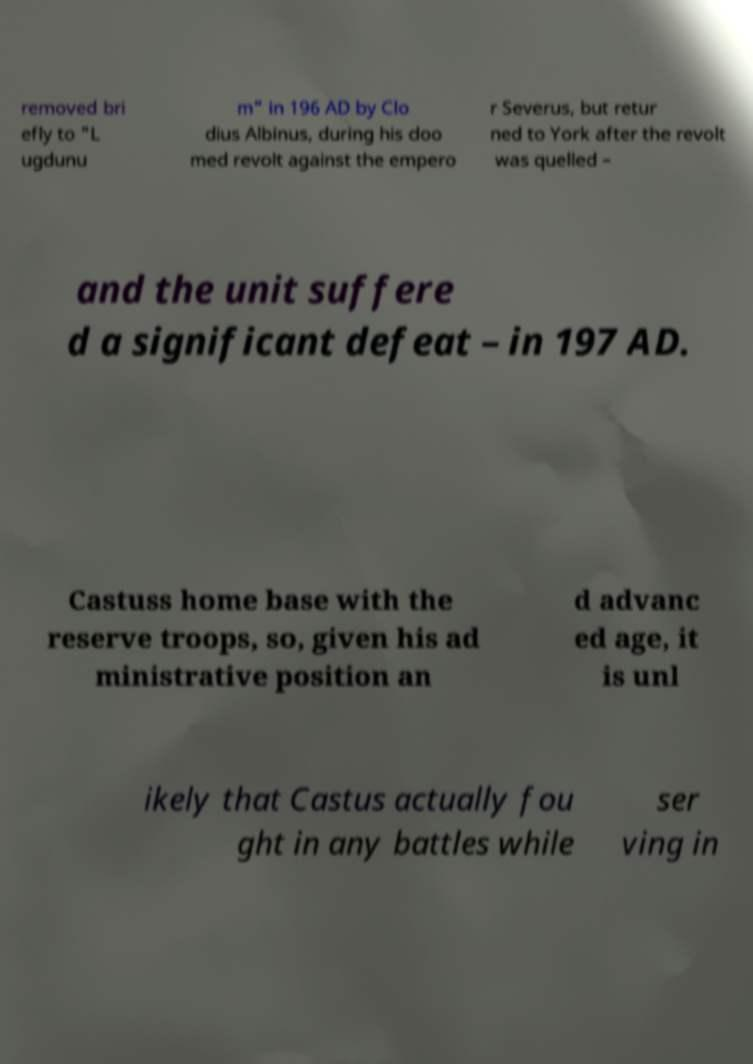Could you assist in decoding the text presented in this image and type it out clearly? removed bri efly to "L ugdunu m" in 196 AD by Clo dius Albinus, during his doo med revolt against the empero r Severus, but retur ned to York after the revolt was quelled – and the unit suffere d a significant defeat – in 197 AD. Castuss home base with the reserve troops, so, given his ad ministrative position an d advanc ed age, it is unl ikely that Castus actually fou ght in any battles while ser ving in 